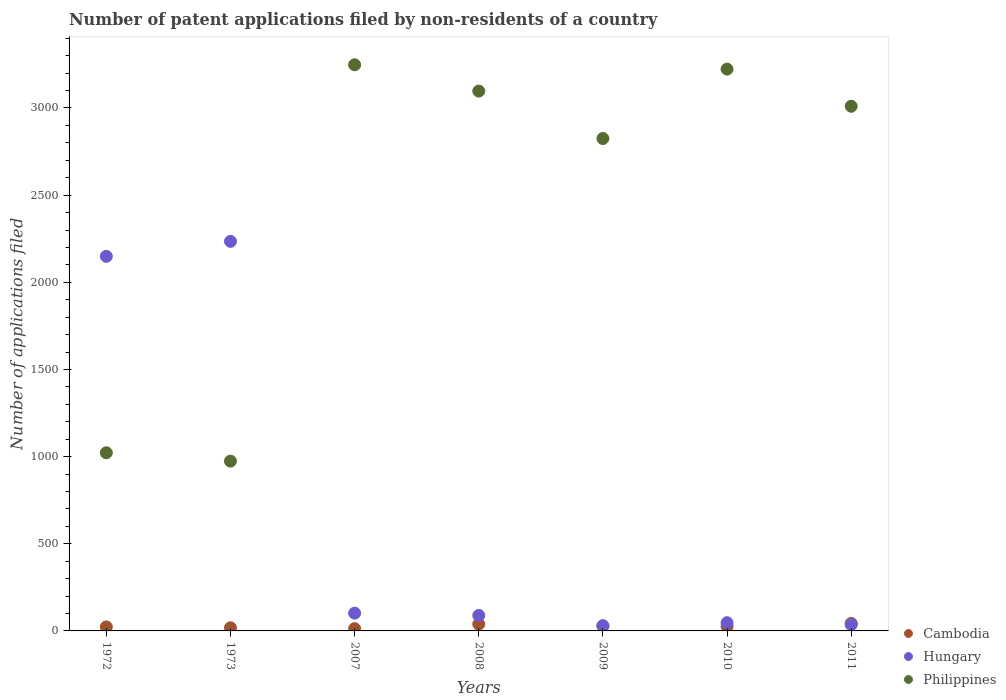How many different coloured dotlines are there?
Your response must be concise. 3. Is the number of dotlines equal to the number of legend labels?
Provide a succinct answer. Yes. What is the number of applications filed in Philippines in 2010?
Your answer should be very brief. 3223. What is the total number of applications filed in Cambodia in the graph?
Make the answer very short. 190. What is the difference between the number of applications filed in Philippines in 2008 and that in 2010?
Your response must be concise. -126. What is the average number of applications filed in Cambodia per year?
Your response must be concise. 27.14. In the year 2011, what is the difference between the number of applications filed in Cambodia and number of applications filed in Philippines?
Offer a terse response. -2967. What is the ratio of the number of applications filed in Hungary in 2007 to that in 2008?
Keep it short and to the point. 1.15. Is the difference between the number of applications filed in Cambodia in 2009 and 2011 greater than the difference between the number of applications filed in Philippines in 2009 and 2011?
Provide a short and direct response. Yes. Is the number of applications filed in Hungary strictly greater than the number of applications filed in Philippines over the years?
Offer a terse response. No. How many dotlines are there?
Make the answer very short. 3. How many years are there in the graph?
Your answer should be compact. 7. Are the values on the major ticks of Y-axis written in scientific E-notation?
Make the answer very short. No. Does the graph contain any zero values?
Keep it short and to the point. No. How are the legend labels stacked?
Your answer should be very brief. Vertical. What is the title of the graph?
Your answer should be very brief. Number of patent applications filed by non-residents of a country. What is the label or title of the X-axis?
Provide a succinct answer. Years. What is the label or title of the Y-axis?
Your answer should be very brief. Number of applications filed. What is the Number of applications filed in Cambodia in 1972?
Provide a succinct answer. 23. What is the Number of applications filed of Hungary in 1972?
Provide a succinct answer. 2149. What is the Number of applications filed of Philippines in 1972?
Offer a terse response. 1022. What is the Number of applications filed of Cambodia in 1973?
Keep it short and to the point. 18. What is the Number of applications filed in Hungary in 1973?
Ensure brevity in your answer.  2235. What is the Number of applications filed of Philippines in 1973?
Offer a very short reply. 974. What is the Number of applications filed of Hungary in 2007?
Keep it short and to the point. 102. What is the Number of applications filed in Philippines in 2007?
Offer a very short reply. 3248. What is the Number of applications filed in Cambodia in 2008?
Make the answer very short. 39. What is the Number of applications filed in Hungary in 2008?
Your answer should be very brief. 89. What is the Number of applications filed in Philippines in 2008?
Your answer should be very brief. 3097. What is the Number of applications filed in Cambodia in 2009?
Your answer should be compact. 28. What is the Number of applications filed of Hungary in 2009?
Offer a very short reply. 30. What is the Number of applications filed of Philippines in 2009?
Provide a succinct answer. 2825. What is the Number of applications filed of Cambodia in 2010?
Offer a very short reply. 26. What is the Number of applications filed in Hungary in 2010?
Give a very brief answer. 47. What is the Number of applications filed of Philippines in 2010?
Offer a very short reply. 3223. What is the Number of applications filed of Cambodia in 2011?
Your response must be concise. 43. What is the Number of applications filed of Philippines in 2011?
Your response must be concise. 3010. Across all years, what is the maximum Number of applications filed in Hungary?
Offer a terse response. 2235. Across all years, what is the maximum Number of applications filed of Philippines?
Your answer should be very brief. 3248. Across all years, what is the minimum Number of applications filed of Philippines?
Keep it short and to the point. 974. What is the total Number of applications filed in Cambodia in the graph?
Give a very brief answer. 190. What is the total Number of applications filed of Hungary in the graph?
Give a very brief answer. 4688. What is the total Number of applications filed of Philippines in the graph?
Your answer should be compact. 1.74e+04. What is the difference between the Number of applications filed of Cambodia in 1972 and that in 1973?
Provide a short and direct response. 5. What is the difference between the Number of applications filed in Hungary in 1972 and that in 1973?
Give a very brief answer. -86. What is the difference between the Number of applications filed of Philippines in 1972 and that in 1973?
Make the answer very short. 48. What is the difference between the Number of applications filed in Cambodia in 1972 and that in 2007?
Your answer should be very brief. 10. What is the difference between the Number of applications filed in Hungary in 1972 and that in 2007?
Provide a succinct answer. 2047. What is the difference between the Number of applications filed of Philippines in 1972 and that in 2007?
Provide a short and direct response. -2226. What is the difference between the Number of applications filed of Cambodia in 1972 and that in 2008?
Ensure brevity in your answer.  -16. What is the difference between the Number of applications filed of Hungary in 1972 and that in 2008?
Give a very brief answer. 2060. What is the difference between the Number of applications filed in Philippines in 1972 and that in 2008?
Your answer should be compact. -2075. What is the difference between the Number of applications filed in Hungary in 1972 and that in 2009?
Keep it short and to the point. 2119. What is the difference between the Number of applications filed in Philippines in 1972 and that in 2009?
Your answer should be compact. -1803. What is the difference between the Number of applications filed of Cambodia in 1972 and that in 2010?
Provide a short and direct response. -3. What is the difference between the Number of applications filed of Hungary in 1972 and that in 2010?
Keep it short and to the point. 2102. What is the difference between the Number of applications filed in Philippines in 1972 and that in 2010?
Your response must be concise. -2201. What is the difference between the Number of applications filed in Cambodia in 1972 and that in 2011?
Your answer should be compact. -20. What is the difference between the Number of applications filed of Hungary in 1972 and that in 2011?
Your answer should be very brief. 2113. What is the difference between the Number of applications filed in Philippines in 1972 and that in 2011?
Make the answer very short. -1988. What is the difference between the Number of applications filed in Hungary in 1973 and that in 2007?
Give a very brief answer. 2133. What is the difference between the Number of applications filed of Philippines in 1973 and that in 2007?
Provide a succinct answer. -2274. What is the difference between the Number of applications filed in Hungary in 1973 and that in 2008?
Offer a very short reply. 2146. What is the difference between the Number of applications filed in Philippines in 1973 and that in 2008?
Keep it short and to the point. -2123. What is the difference between the Number of applications filed in Cambodia in 1973 and that in 2009?
Provide a short and direct response. -10. What is the difference between the Number of applications filed of Hungary in 1973 and that in 2009?
Your answer should be very brief. 2205. What is the difference between the Number of applications filed in Philippines in 1973 and that in 2009?
Your answer should be compact. -1851. What is the difference between the Number of applications filed of Cambodia in 1973 and that in 2010?
Keep it short and to the point. -8. What is the difference between the Number of applications filed of Hungary in 1973 and that in 2010?
Offer a terse response. 2188. What is the difference between the Number of applications filed of Philippines in 1973 and that in 2010?
Make the answer very short. -2249. What is the difference between the Number of applications filed in Cambodia in 1973 and that in 2011?
Make the answer very short. -25. What is the difference between the Number of applications filed in Hungary in 1973 and that in 2011?
Give a very brief answer. 2199. What is the difference between the Number of applications filed of Philippines in 1973 and that in 2011?
Offer a very short reply. -2036. What is the difference between the Number of applications filed in Hungary in 2007 and that in 2008?
Your answer should be very brief. 13. What is the difference between the Number of applications filed of Philippines in 2007 and that in 2008?
Ensure brevity in your answer.  151. What is the difference between the Number of applications filed in Cambodia in 2007 and that in 2009?
Ensure brevity in your answer.  -15. What is the difference between the Number of applications filed in Philippines in 2007 and that in 2009?
Your answer should be compact. 423. What is the difference between the Number of applications filed in Cambodia in 2007 and that in 2010?
Keep it short and to the point. -13. What is the difference between the Number of applications filed in Hungary in 2007 and that in 2010?
Ensure brevity in your answer.  55. What is the difference between the Number of applications filed of Cambodia in 2007 and that in 2011?
Keep it short and to the point. -30. What is the difference between the Number of applications filed of Hungary in 2007 and that in 2011?
Your answer should be compact. 66. What is the difference between the Number of applications filed in Philippines in 2007 and that in 2011?
Offer a terse response. 238. What is the difference between the Number of applications filed in Philippines in 2008 and that in 2009?
Keep it short and to the point. 272. What is the difference between the Number of applications filed of Cambodia in 2008 and that in 2010?
Your response must be concise. 13. What is the difference between the Number of applications filed of Hungary in 2008 and that in 2010?
Your answer should be very brief. 42. What is the difference between the Number of applications filed of Philippines in 2008 and that in 2010?
Give a very brief answer. -126. What is the difference between the Number of applications filed in Cambodia in 2009 and that in 2010?
Your answer should be very brief. 2. What is the difference between the Number of applications filed in Philippines in 2009 and that in 2010?
Make the answer very short. -398. What is the difference between the Number of applications filed in Philippines in 2009 and that in 2011?
Offer a very short reply. -185. What is the difference between the Number of applications filed of Philippines in 2010 and that in 2011?
Offer a very short reply. 213. What is the difference between the Number of applications filed in Cambodia in 1972 and the Number of applications filed in Hungary in 1973?
Make the answer very short. -2212. What is the difference between the Number of applications filed of Cambodia in 1972 and the Number of applications filed of Philippines in 1973?
Give a very brief answer. -951. What is the difference between the Number of applications filed in Hungary in 1972 and the Number of applications filed in Philippines in 1973?
Your response must be concise. 1175. What is the difference between the Number of applications filed in Cambodia in 1972 and the Number of applications filed in Hungary in 2007?
Offer a very short reply. -79. What is the difference between the Number of applications filed of Cambodia in 1972 and the Number of applications filed of Philippines in 2007?
Offer a terse response. -3225. What is the difference between the Number of applications filed of Hungary in 1972 and the Number of applications filed of Philippines in 2007?
Your response must be concise. -1099. What is the difference between the Number of applications filed in Cambodia in 1972 and the Number of applications filed in Hungary in 2008?
Keep it short and to the point. -66. What is the difference between the Number of applications filed of Cambodia in 1972 and the Number of applications filed of Philippines in 2008?
Ensure brevity in your answer.  -3074. What is the difference between the Number of applications filed of Hungary in 1972 and the Number of applications filed of Philippines in 2008?
Offer a terse response. -948. What is the difference between the Number of applications filed in Cambodia in 1972 and the Number of applications filed in Hungary in 2009?
Provide a succinct answer. -7. What is the difference between the Number of applications filed in Cambodia in 1972 and the Number of applications filed in Philippines in 2009?
Offer a terse response. -2802. What is the difference between the Number of applications filed of Hungary in 1972 and the Number of applications filed of Philippines in 2009?
Provide a succinct answer. -676. What is the difference between the Number of applications filed in Cambodia in 1972 and the Number of applications filed in Hungary in 2010?
Offer a very short reply. -24. What is the difference between the Number of applications filed of Cambodia in 1972 and the Number of applications filed of Philippines in 2010?
Your response must be concise. -3200. What is the difference between the Number of applications filed in Hungary in 1972 and the Number of applications filed in Philippines in 2010?
Your answer should be very brief. -1074. What is the difference between the Number of applications filed of Cambodia in 1972 and the Number of applications filed of Hungary in 2011?
Your response must be concise. -13. What is the difference between the Number of applications filed in Cambodia in 1972 and the Number of applications filed in Philippines in 2011?
Offer a terse response. -2987. What is the difference between the Number of applications filed of Hungary in 1972 and the Number of applications filed of Philippines in 2011?
Offer a very short reply. -861. What is the difference between the Number of applications filed of Cambodia in 1973 and the Number of applications filed of Hungary in 2007?
Provide a short and direct response. -84. What is the difference between the Number of applications filed in Cambodia in 1973 and the Number of applications filed in Philippines in 2007?
Offer a terse response. -3230. What is the difference between the Number of applications filed of Hungary in 1973 and the Number of applications filed of Philippines in 2007?
Keep it short and to the point. -1013. What is the difference between the Number of applications filed in Cambodia in 1973 and the Number of applications filed in Hungary in 2008?
Keep it short and to the point. -71. What is the difference between the Number of applications filed of Cambodia in 1973 and the Number of applications filed of Philippines in 2008?
Your answer should be very brief. -3079. What is the difference between the Number of applications filed in Hungary in 1973 and the Number of applications filed in Philippines in 2008?
Provide a short and direct response. -862. What is the difference between the Number of applications filed of Cambodia in 1973 and the Number of applications filed of Hungary in 2009?
Give a very brief answer. -12. What is the difference between the Number of applications filed in Cambodia in 1973 and the Number of applications filed in Philippines in 2009?
Offer a very short reply. -2807. What is the difference between the Number of applications filed of Hungary in 1973 and the Number of applications filed of Philippines in 2009?
Your answer should be compact. -590. What is the difference between the Number of applications filed in Cambodia in 1973 and the Number of applications filed in Hungary in 2010?
Provide a succinct answer. -29. What is the difference between the Number of applications filed of Cambodia in 1973 and the Number of applications filed of Philippines in 2010?
Offer a terse response. -3205. What is the difference between the Number of applications filed of Hungary in 1973 and the Number of applications filed of Philippines in 2010?
Keep it short and to the point. -988. What is the difference between the Number of applications filed in Cambodia in 1973 and the Number of applications filed in Hungary in 2011?
Your answer should be compact. -18. What is the difference between the Number of applications filed of Cambodia in 1973 and the Number of applications filed of Philippines in 2011?
Your answer should be very brief. -2992. What is the difference between the Number of applications filed in Hungary in 1973 and the Number of applications filed in Philippines in 2011?
Offer a terse response. -775. What is the difference between the Number of applications filed in Cambodia in 2007 and the Number of applications filed in Hungary in 2008?
Make the answer very short. -76. What is the difference between the Number of applications filed in Cambodia in 2007 and the Number of applications filed in Philippines in 2008?
Offer a terse response. -3084. What is the difference between the Number of applications filed in Hungary in 2007 and the Number of applications filed in Philippines in 2008?
Provide a short and direct response. -2995. What is the difference between the Number of applications filed in Cambodia in 2007 and the Number of applications filed in Hungary in 2009?
Your response must be concise. -17. What is the difference between the Number of applications filed in Cambodia in 2007 and the Number of applications filed in Philippines in 2009?
Keep it short and to the point. -2812. What is the difference between the Number of applications filed of Hungary in 2007 and the Number of applications filed of Philippines in 2009?
Provide a succinct answer. -2723. What is the difference between the Number of applications filed of Cambodia in 2007 and the Number of applications filed of Hungary in 2010?
Keep it short and to the point. -34. What is the difference between the Number of applications filed of Cambodia in 2007 and the Number of applications filed of Philippines in 2010?
Give a very brief answer. -3210. What is the difference between the Number of applications filed in Hungary in 2007 and the Number of applications filed in Philippines in 2010?
Provide a short and direct response. -3121. What is the difference between the Number of applications filed in Cambodia in 2007 and the Number of applications filed in Philippines in 2011?
Keep it short and to the point. -2997. What is the difference between the Number of applications filed of Hungary in 2007 and the Number of applications filed of Philippines in 2011?
Your answer should be compact. -2908. What is the difference between the Number of applications filed in Cambodia in 2008 and the Number of applications filed in Philippines in 2009?
Your response must be concise. -2786. What is the difference between the Number of applications filed in Hungary in 2008 and the Number of applications filed in Philippines in 2009?
Provide a short and direct response. -2736. What is the difference between the Number of applications filed in Cambodia in 2008 and the Number of applications filed in Hungary in 2010?
Make the answer very short. -8. What is the difference between the Number of applications filed in Cambodia in 2008 and the Number of applications filed in Philippines in 2010?
Keep it short and to the point. -3184. What is the difference between the Number of applications filed in Hungary in 2008 and the Number of applications filed in Philippines in 2010?
Ensure brevity in your answer.  -3134. What is the difference between the Number of applications filed of Cambodia in 2008 and the Number of applications filed of Philippines in 2011?
Give a very brief answer. -2971. What is the difference between the Number of applications filed of Hungary in 2008 and the Number of applications filed of Philippines in 2011?
Provide a succinct answer. -2921. What is the difference between the Number of applications filed of Cambodia in 2009 and the Number of applications filed of Hungary in 2010?
Ensure brevity in your answer.  -19. What is the difference between the Number of applications filed of Cambodia in 2009 and the Number of applications filed of Philippines in 2010?
Your response must be concise. -3195. What is the difference between the Number of applications filed in Hungary in 2009 and the Number of applications filed in Philippines in 2010?
Keep it short and to the point. -3193. What is the difference between the Number of applications filed of Cambodia in 2009 and the Number of applications filed of Philippines in 2011?
Give a very brief answer. -2982. What is the difference between the Number of applications filed in Hungary in 2009 and the Number of applications filed in Philippines in 2011?
Keep it short and to the point. -2980. What is the difference between the Number of applications filed in Cambodia in 2010 and the Number of applications filed in Philippines in 2011?
Keep it short and to the point. -2984. What is the difference between the Number of applications filed of Hungary in 2010 and the Number of applications filed of Philippines in 2011?
Keep it short and to the point. -2963. What is the average Number of applications filed in Cambodia per year?
Your response must be concise. 27.14. What is the average Number of applications filed in Hungary per year?
Provide a succinct answer. 669.71. What is the average Number of applications filed of Philippines per year?
Give a very brief answer. 2485.57. In the year 1972, what is the difference between the Number of applications filed of Cambodia and Number of applications filed of Hungary?
Offer a terse response. -2126. In the year 1972, what is the difference between the Number of applications filed in Cambodia and Number of applications filed in Philippines?
Provide a short and direct response. -999. In the year 1972, what is the difference between the Number of applications filed of Hungary and Number of applications filed of Philippines?
Your answer should be compact. 1127. In the year 1973, what is the difference between the Number of applications filed in Cambodia and Number of applications filed in Hungary?
Make the answer very short. -2217. In the year 1973, what is the difference between the Number of applications filed of Cambodia and Number of applications filed of Philippines?
Your answer should be compact. -956. In the year 1973, what is the difference between the Number of applications filed of Hungary and Number of applications filed of Philippines?
Your answer should be very brief. 1261. In the year 2007, what is the difference between the Number of applications filed of Cambodia and Number of applications filed of Hungary?
Your answer should be compact. -89. In the year 2007, what is the difference between the Number of applications filed of Cambodia and Number of applications filed of Philippines?
Your response must be concise. -3235. In the year 2007, what is the difference between the Number of applications filed of Hungary and Number of applications filed of Philippines?
Your answer should be compact. -3146. In the year 2008, what is the difference between the Number of applications filed of Cambodia and Number of applications filed of Philippines?
Offer a terse response. -3058. In the year 2008, what is the difference between the Number of applications filed of Hungary and Number of applications filed of Philippines?
Your answer should be very brief. -3008. In the year 2009, what is the difference between the Number of applications filed of Cambodia and Number of applications filed of Hungary?
Provide a short and direct response. -2. In the year 2009, what is the difference between the Number of applications filed of Cambodia and Number of applications filed of Philippines?
Offer a very short reply. -2797. In the year 2009, what is the difference between the Number of applications filed of Hungary and Number of applications filed of Philippines?
Provide a short and direct response. -2795. In the year 2010, what is the difference between the Number of applications filed in Cambodia and Number of applications filed in Hungary?
Your response must be concise. -21. In the year 2010, what is the difference between the Number of applications filed in Cambodia and Number of applications filed in Philippines?
Make the answer very short. -3197. In the year 2010, what is the difference between the Number of applications filed in Hungary and Number of applications filed in Philippines?
Make the answer very short. -3176. In the year 2011, what is the difference between the Number of applications filed of Cambodia and Number of applications filed of Hungary?
Offer a very short reply. 7. In the year 2011, what is the difference between the Number of applications filed of Cambodia and Number of applications filed of Philippines?
Ensure brevity in your answer.  -2967. In the year 2011, what is the difference between the Number of applications filed of Hungary and Number of applications filed of Philippines?
Offer a terse response. -2974. What is the ratio of the Number of applications filed of Cambodia in 1972 to that in 1973?
Make the answer very short. 1.28. What is the ratio of the Number of applications filed in Hungary in 1972 to that in 1973?
Offer a terse response. 0.96. What is the ratio of the Number of applications filed in Philippines in 1972 to that in 1973?
Give a very brief answer. 1.05. What is the ratio of the Number of applications filed in Cambodia in 1972 to that in 2007?
Offer a terse response. 1.77. What is the ratio of the Number of applications filed of Hungary in 1972 to that in 2007?
Give a very brief answer. 21.07. What is the ratio of the Number of applications filed in Philippines in 1972 to that in 2007?
Offer a very short reply. 0.31. What is the ratio of the Number of applications filed in Cambodia in 1972 to that in 2008?
Make the answer very short. 0.59. What is the ratio of the Number of applications filed of Hungary in 1972 to that in 2008?
Provide a short and direct response. 24.15. What is the ratio of the Number of applications filed in Philippines in 1972 to that in 2008?
Your answer should be very brief. 0.33. What is the ratio of the Number of applications filed in Cambodia in 1972 to that in 2009?
Offer a terse response. 0.82. What is the ratio of the Number of applications filed of Hungary in 1972 to that in 2009?
Your answer should be compact. 71.63. What is the ratio of the Number of applications filed of Philippines in 1972 to that in 2009?
Give a very brief answer. 0.36. What is the ratio of the Number of applications filed in Cambodia in 1972 to that in 2010?
Your answer should be compact. 0.88. What is the ratio of the Number of applications filed in Hungary in 1972 to that in 2010?
Your answer should be compact. 45.72. What is the ratio of the Number of applications filed of Philippines in 1972 to that in 2010?
Ensure brevity in your answer.  0.32. What is the ratio of the Number of applications filed of Cambodia in 1972 to that in 2011?
Make the answer very short. 0.53. What is the ratio of the Number of applications filed in Hungary in 1972 to that in 2011?
Offer a very short reply. 59.69. What is the ratio of the Number of applications filed in Philippines in 1972 to that in 2011?
Provide a short and direct response. 0.34. What is the ratio of the Number of applications filed in Cambodia in 1973 to that in 2007?
Your answer should be compact. 1.38. What is the ratio of the Number of applications filed of Hungary in 1973 to that in 2007?
Your response must be concise. 21.91. What is the ratio of the Number of applications filed of Philippines in 1973 to that in 2007?
Your response must be concise. 0.3. What is the ratio of the Number of applications filed of Cambodia in 1973 to that in 2008?
Your answer should be compact. 0.46. What is the ratio of the Number of applications filed of Hungary in 1973 to that in 2008?
Give a very brief answer. 25.11. What is the ratio of the Number of applications filed in Philippines in 1973 to that in 2008?
Provide a succinct answer. 0.31. What is the ratio of the Number of applications filed in Cambodia in 1973 to that in 2009?
Offer a terse response. 0.64. What is the ratio of the Number of applications filed of Hungary in 1973 to that in 2009?
Give a very brief answer. 74.5. What is the ratio of the Number of applications filed in Philippines in 1973 to that in 2009?
Keep it short and to the point. 0.34. What is the ratio of the Number of applications filed of Cambodia in 1973 to that in 2010?
Keep it short and to the point. 0.69. What is the ratio of the Number of applications filed in Hungary in 1973 to that in 2010?
Give a very brief answer. 47.55. What is the ratio of the Number of applications filed of Philippines in 1973 to that in 2010?
Give a very brief answer. 0.3. What is the ratio of the Number of applications filed in Cambodia in 1973 to that in 2011?
Your answer should be very brief. 0.42. What is the ratio of the Number of applications filed of Hungary in 1973 to that in 2011?
Your answer should be compact. 62.08. What is the ratio of the Number of applications filed of Philippines in 1973 to that in 2011?
Provide a short and direct response. 0.32. What is the ratio of the Number of applications filed of Hungary in 2007 to that in 2008?
Give a very brief answer. 1.15. What is the ratio of the Number of applications filed of Philippines in 2007 to that in 2008?
Ensure brevity in your answer.  1.05. What is the ratio of the Number of applications filed in Cambodia in 2007 to that in 2009?
Your answer should be very brief. 0.46. What is the ratio of the Number of applications filed of Hungary in 2007 to that in 2009?
Give a very brief answer. 3.4. What is the ratio of the Number of applications filed of Philippines in 2007 to that in 2009?
Offer a terse response. 1.15. What is the ratio of the Number of applications filed of Hungary in 2007 to that in 2010?
Offer a terse response. 2.17. What is the ratio of the Number of applications filed in Cambodia in 2007 to that in 2011?
Make the answer very short. 0.3. What is the ratio of the Number of applications filed of Hungary in 2007 to that in 2011?
Ensure brevity in your answer.  2.83. What is the ratio of the Number of applications filed of Philippines in 2007 to that in 2011?
Provide a short and direct response. 1.08. What is the ratio of the Number of applications filed in Cambodia in 2008 to that in 2009?
Offer a very short reply. 1.39. What is the ratio of the Number of applications filed in Hungary in 2008 to that in 2009?
Provide a short and direct response. 2.97. What is the ratio of the Number of applications filed in Philippines in 2008 to that in 2009?
Give a very brief answer. 1.1. What is the ratio of the Number of applications filed in Hungary in 2008 to that in 2010?
Provide a succinct answer. 1.89. What is the ratio of the Number of applications filed in Philippines in 2008 to that in 2010?
Offer a very short reply. 0.96. What is the ratio of the Number of applications filed in Cambodia in 2008 to that in 2011?
Offer a very short reply. 0.91. What is the ratio of the Number of applications filed of Hungary in 2008 to that in 2011?
Ensure brevity in your answer.  2.47. What is the ratio of the Number of applications filed in Philippines in 2008 to that in 2011?
Keep it short and to the point. 1.03. What is the ratio of the Number of applications filed in Hungary in 2009 to that in 2010?
Your response must be concise. 0.64. What is the ratio of the Number of applications filed of Philippines in 2009 to that in 2010?
Your response must be concise. 0.88. What is the ratio of the Number of applications filed in Cambodia in 2009 to that in 2011?
Your answer should be compact. 0.65. What is the ratio of the Number of applications filed in Hungary in 2009 to that in 2011?
Make the answer very short. 0.83. What is the ratio of the Number of applications filed of Philippines in 2009 to that in 2011?
Give a very brief answer. 0.94. What is the ratio of the Number of applications filed of Cambodia in 2010 to that in 2011?
Offer a terse response. 0.6. What is the ratio of the Number of applications filed of Hungary in 2010 to that in 2011?
Provide a succinct answer. 1.31. What is the ratio of the Number of applications filed in Philippines in 2010 to that in 2011?
Offer a terse response. 1.07. What is the difference between the highest and the lowest Number of applications filed in Cambodia?
Your answer should be very brief. 30. What is the difference between the highest and the lowest Number of applications filed of Hungary?
Provide a succinct answer. 2205. What is the difference between the highest and the lowest Number of applications filed of Philippines?
Give a very brief answer. 2274. 